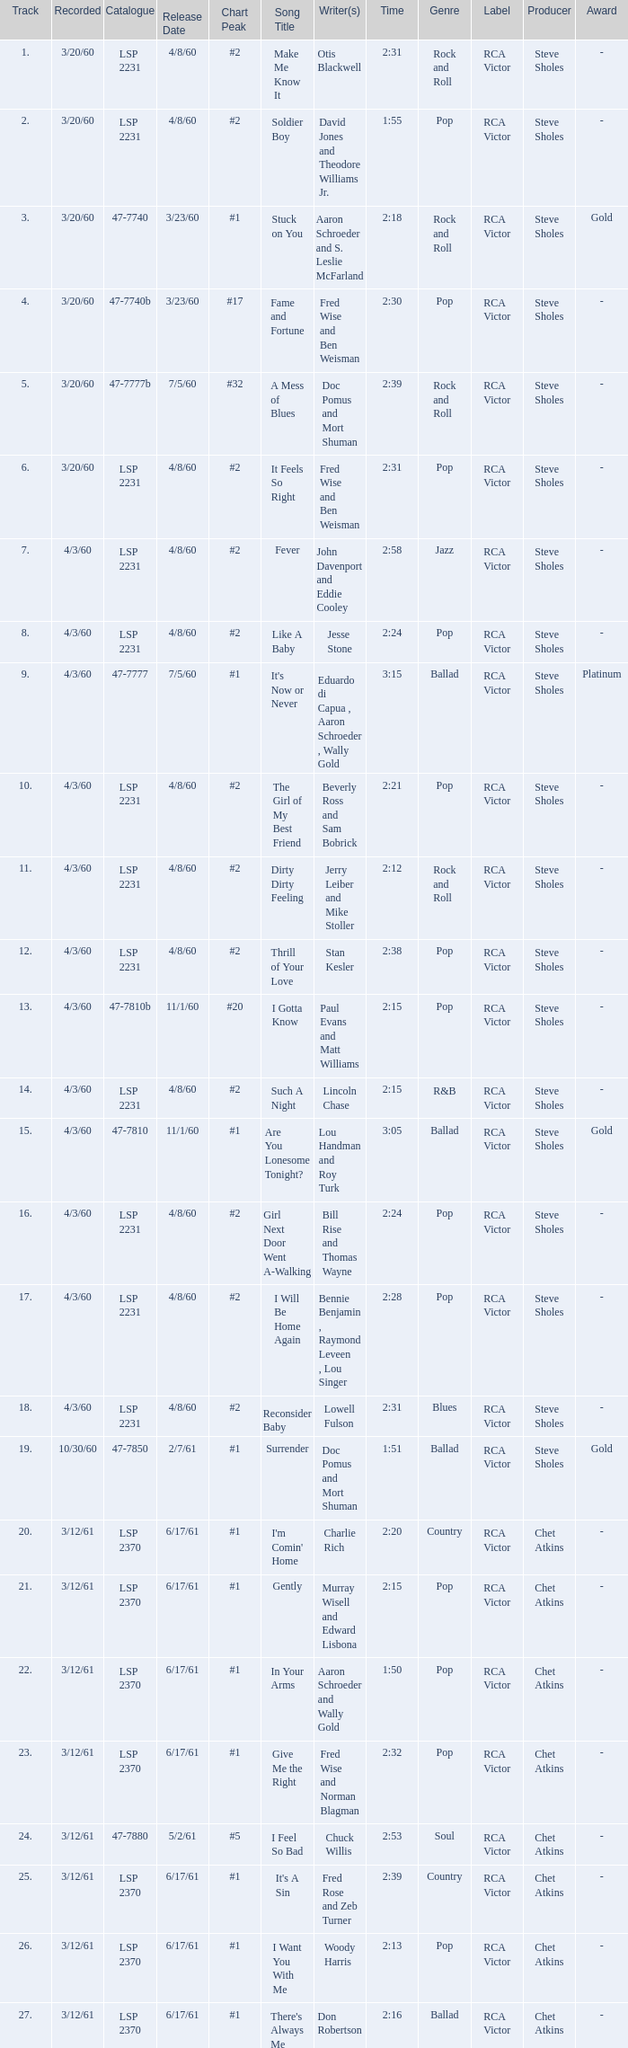On songs that have a release date of 6/17/61, a track larger than 20, and a writer of Woody Harris, what is the chart peak? #1. 